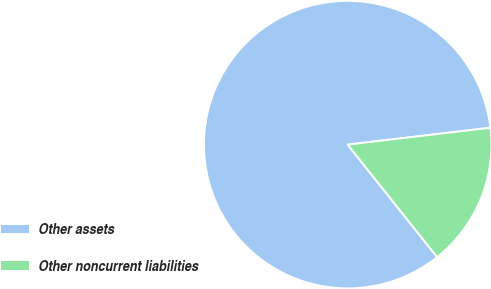Convert chart to OTSL. <chart><loc_0><loc_0><loc_500><loc_500><pie_chart><fcel>Other assets<fcel>Other noncurrent liabilities<nl><fcel>83.82%<fcel>16.18%<nl></chart> 